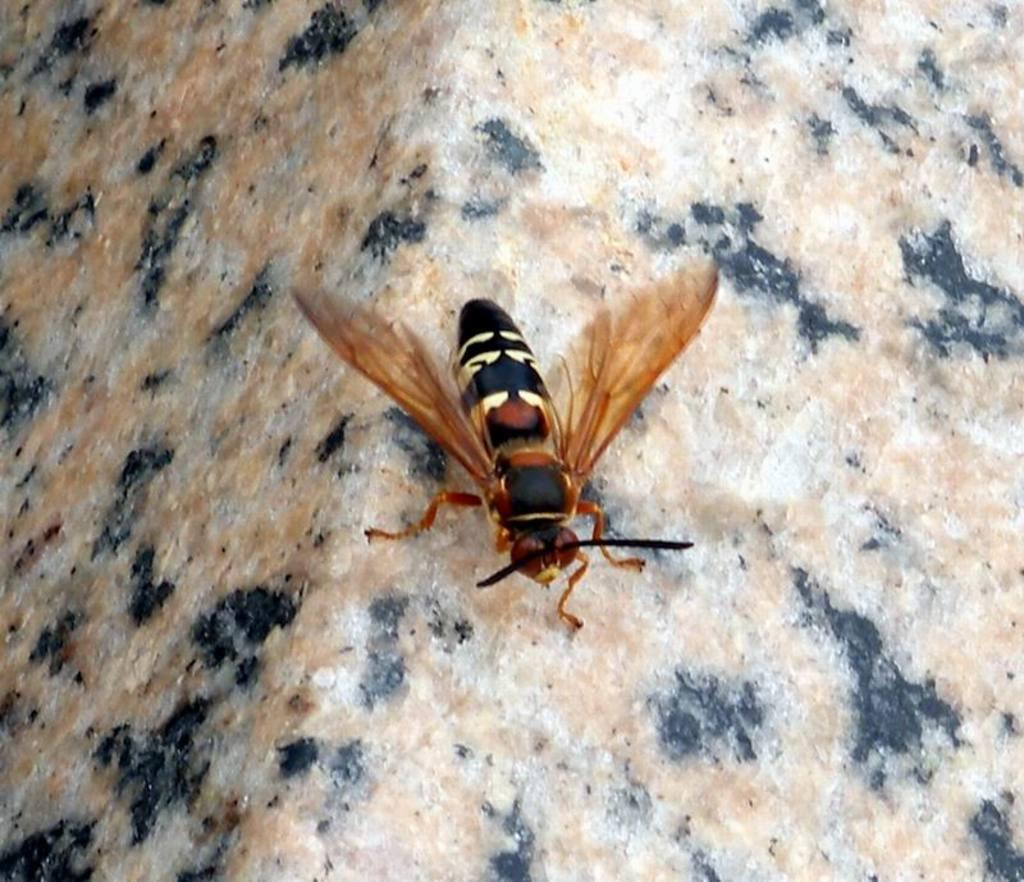What is present in the image that has wings? There is a fly in the image that has wings. What is the color of the fly in the image? The fly in the image is brown in color. What is located at the bottom of the image? There is a rock at the bottom of the image. How many cows are exchanging mass in the image? There are no cows present in the image, nor is there any exchange of mass occurring. 